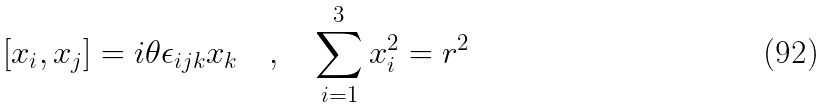<formula> <loc_0><loc_0><loc_500><loc_500>[ x _ { i } , x _ { j } ] = i \theta \epsilon _ { i j k } x _ { k } \quad , \quad \sum _ { i = 1 } ^ { 3 } x _ { i } ^ { 2 } = r ^ { 2 }</formula> 